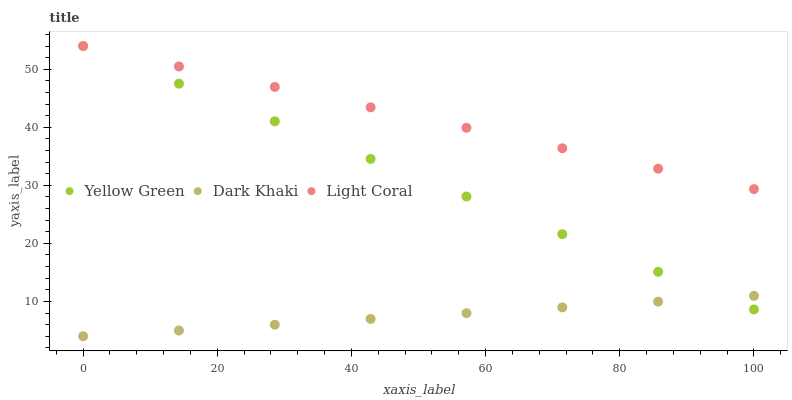Does Dark Khaki have the minimum area under the curve?
Answer yes or no. Yes. Does Light Coral have the maximum area under the curve?
Answer yes or no. Yes. Does Yellow Green have the minimum area under the curve?
Answer yes or no. No. Does Yellow Green have the maximum area under the curve?
Answer yes or no. No. Is Dark Khaki the smoothest?
Answer yes or no. Yes. Is Light Coral the roughest?
Answer yes or no. Yes. Is Yellow Green the smoothest?
Answer yes or no. No. Is Yellow Green the roughest?
Answer yes or no. No. Does Dark Khaki have the lowest value?
Answer yes or no. Yes. Does Yellow Green have the lowest value?
Answer yes or no. No. Does Yellow Green have the highest value?
Answer yes or no. Yes. Is Dark Khaki less than Light Coral?
Answer yes or no. Yes. Is Light Coral greater than Dark Khaki?
Answer yes or no. Yes. Does Yellow Green intersect Dark Khaki?
Answer yes or no. Yes. Is Yellow Green less than Dark Khaki?
Answer yes or no. No. Is Yellow Green greater than Dark Khaki?
Answer yes or no. No. Does Dark Khaki intersect Light Coral?
Answer yes or no. No. 